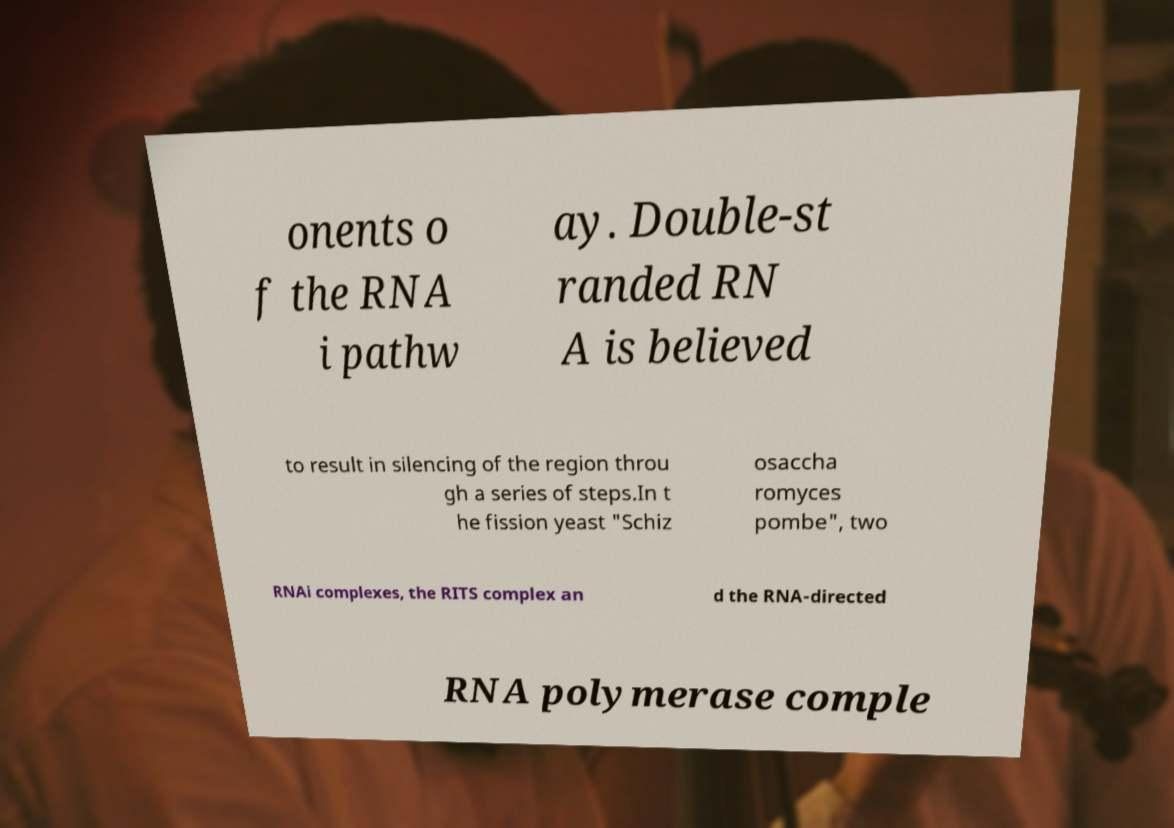Please identify and transcribe the text found in this image. onents o f the RNA i pathw ay. Double-st randed RN A is believed to result in silencing of the region throu gh a series of steps.In t he fission yeast "Schiz osaccha romyces pombe", two RNAi complexes, the RITS complex an d the RNA-directed RNA polymerase comple 